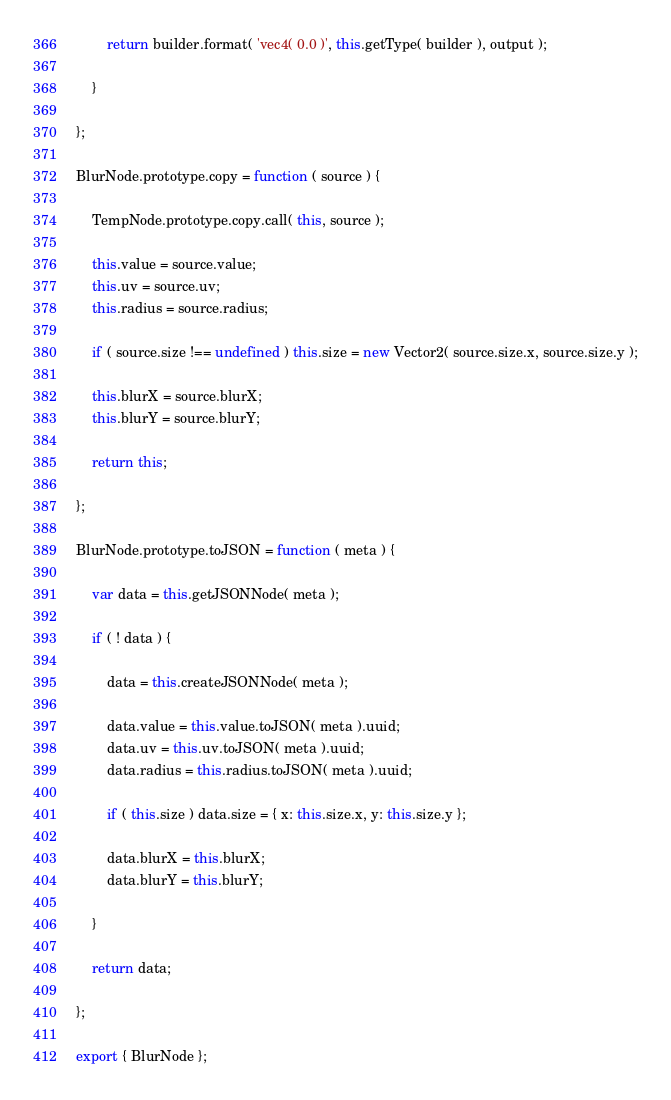Convert code to text. <code><loc_0><loc_0><loc_500><loc_500><_JavaScript_>		return builder.format( 'vec4( 0.0 )', this.getType( builder ), output );

	}

};

BlurNode.prototype.copy = function ( source ) {

	TempNode.prototype.copy.call( this, source );

	this.value = source.value;
	this.uv = source.uv;
	this.radius = source.radius;

	if ( source.size !== undefined ) this.size = new Vector2( source.size.x, source.size.y );

	this.blurX = source.blurX;
	this.blurY = source.blurY;

	return this;

};

BlurNode.prototype.toJSON = function ( meta ) {

	var data = this.getJSONNode( meta );

	if ( ! data ) {

		data = this.createJSONNode( meta );

		data.value = this.value.toJSON( meta ).uuid;
		data.uv = this.uv.toJSON( meta ).uuid;
		data.radius = this.radius.toJSON( meta ).uuid;

		if ( this.size ) data.size = { x: this.size.x, y: this.size.y };

		data.blurX = this.blurX;
		data.blurY = this.blurY;

	}

	return data;

};

export { BlurNode };
</code> 